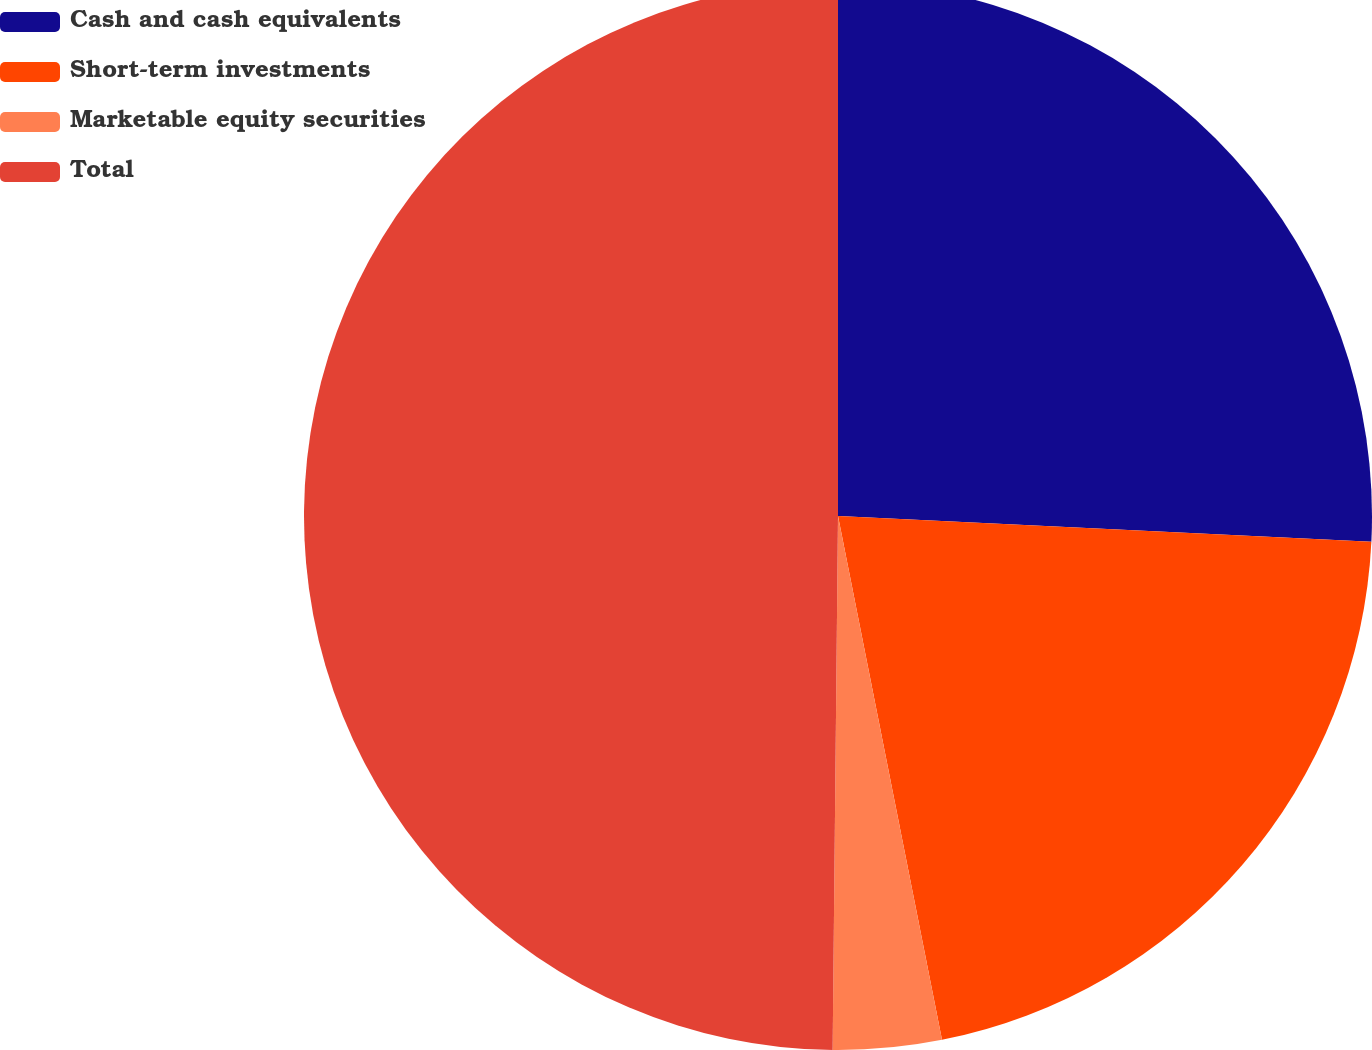Convert chart. <chart><loc_0><loc_0><loc_500><loc_500><pie_chart><fcel>Cash and cash equivalents<fcel>Short-term investments<fcel>Marketable equity securities<fcel>Total<nl><fcel>25.77%<fcel>21.11%<fcel>3.28%<fcel>49.84%<nl></chart> 